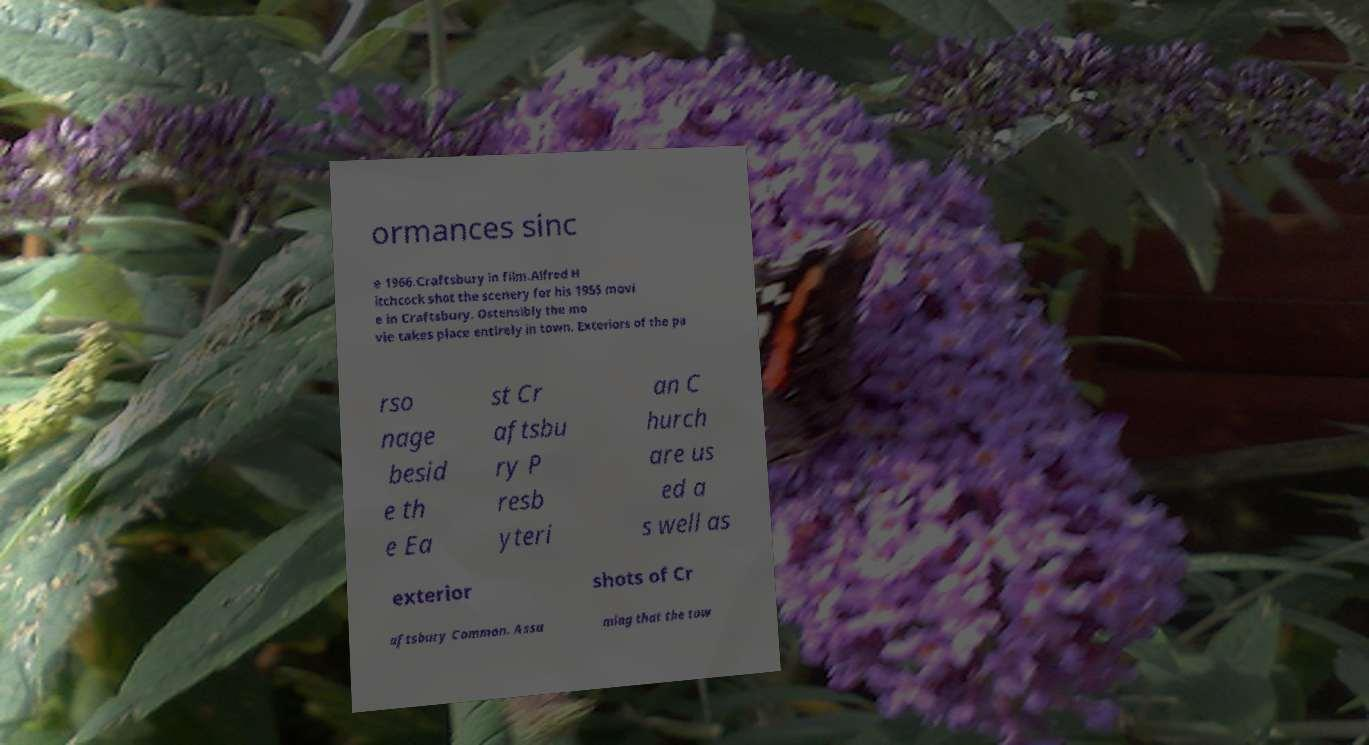Please identify and transcribe the text found in this image. ormances sinc e 1966.Craftsbury in film.Alfred H itchcock shot the scenery for his 1955 movi e in Craftsbury. Ostensibly the mo vie takes place entirely in town. Exteriors of the pa rso nage besid e th e Ea st Cr aftsbu ry P resb yteri an C hurch are us ed a s well as exterior shots of Cr aftsbury Common. Assu ming that the tow 